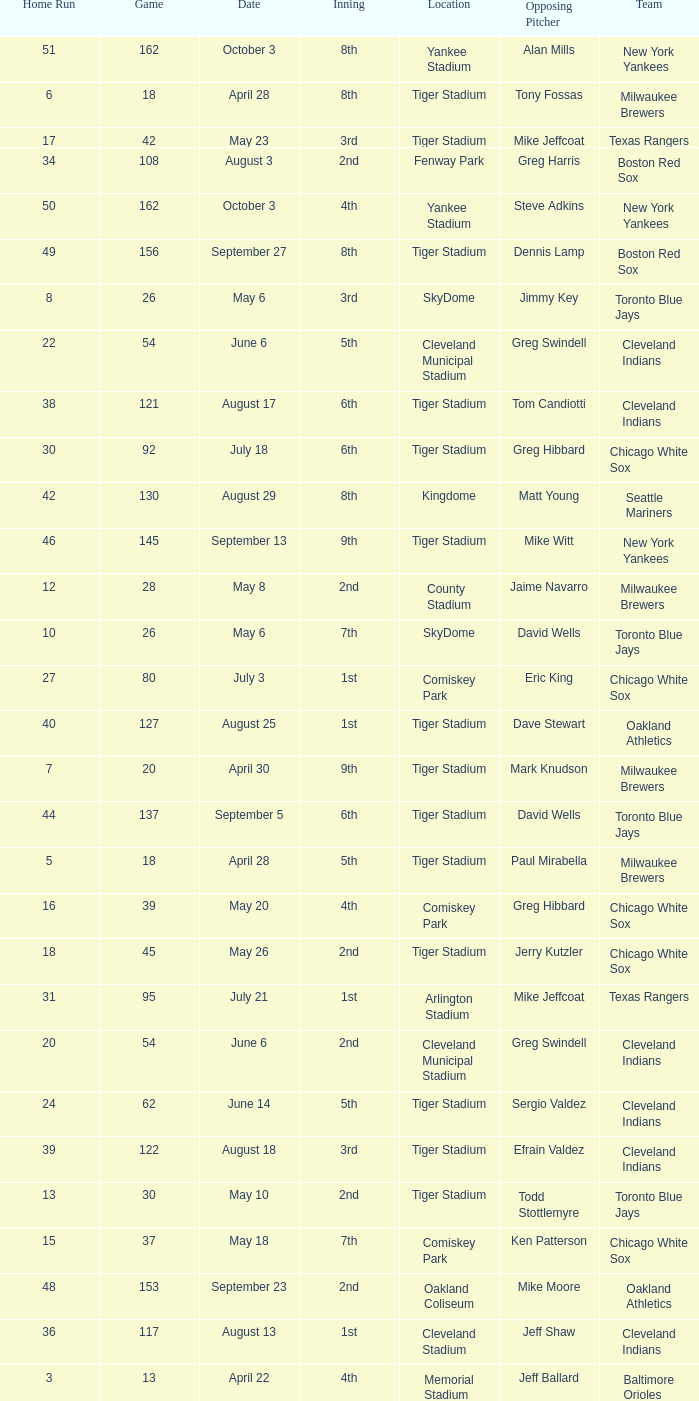During efrain valdez's pitching, what was the maximum home run? 39.0. Help me parse the entirety of this table. {'header': ['Home Run', 'Game', 'Date', 'Inning', 'Location', 'Opposing Pitcher', 'Team'], 'rows': [['51', '162', 'October 3', '8th', 'Yankee Stadium', 'Alan Mills', 'New York Yankees'], ['6', '18', 'April 28', '8th', 'Tiger Stadium', 'Tony Fossas', 'Milwaukee Brewers'], ['17', '42', 'May 23', '3rd', 'Tiger Stadium', 'Mike Jeffcoat', 'Texas Rangers'], ['34', '108', 'August 3', '2nd', 'Fenway Park', 'Greg Harris', 'Boston Red Sox'], ['50', '162', 'October 3', '4th', 'Yankee Stadium', 'Steve Adkins', 'New York Yankees'], ['49', '156', 'September 27', '8th', 'Tiger Stadium', 'Dennis Lamp', 'Boston Red Sox'], ['8', '26', 'May 6', '3rd', 'SkyDome', 'Jimmy Key', 'Toronto Blue Jays'], ['22', '54', 'June 6', '5th', 'Cleveland Municipal Stadium', 'Greg Swindell', 'Cleveland Indians'], ['38', '121', 'August 17', '6th', 'Tiger Stadium', 'Tom Candiotti', 'Cleveland Indians'], ['30', '92', 'July 18', '6th', 'Tiger Stadium', 'Greg Hibbard', 'Chicago White Sox'], ['42', '130', 'August 29', '8th', 'Kingdome', 'Matt Young', 'Seattle Mariners'], ['46', '145', 'September 13', '9th', 'Tiger Stadium', 'Mike Witt', 'New York Yankees'], ['12', '28', 'May 8', '2nd', 'County Stadium', 'Jaime Navarro', 'Milwaukee Brewers'], ['10', '26', 'May 6', '7th', 'SkyDome', 'David Wells', 'Toronto Blue Jays'], ['27', '80', 'July 3', '1st', 'Comiskey Park', 'Eric King', 'Chicago White Sox'], ['40', '127', 'August 25', '1st', 'Tiger Stadium', 'Dave Stewart', 'Oakland Athletics'], ['7', '20', 'April 30', '9th', 'Tiger Stadium', 'Mark Knudson', 'Milwaukee Brewers'], ['44', '137', 'September 5', '6th', 'Tiger Stadium', 'David Wells', 'Toronto Blue Jays'], ['5', '18', 'April 28', '5th', 'Tiger Stadium', 'Paul Mirabella', 'Milwaukee Brewers'], ['16', '39', 'May 20', '4th', 'Comiskey Park', 'Greg Hibbard', 'Chicago White Sox'], ['18', '45', 'May 26', '2nd', 'Tiger Stadium', 'Jerry Kutzler', 'Chicago White Sox'], ['31', '95', 'July 21', '1st', 'Arlington Stadium', 'Mike Jeffcoat', 'Texas Rangers'], ['20', '54', 'June 6', '2nd', 'Cleveland Municipal Stadium', 'Greg Swindell', 'Cleveland Indians'], ['24', '62', 'June 14', '5th', 'Tiger Stadium', 'Sergio Valdez', 'Cleveland Indians'], ['39', '122', 'August 18', '3rd', 'Tiger Stadium', 'Efrain Valdez', 'Cleveland Indians'], ['13', '30', 'May 10', '2nd', 'Tiger Stadium', 'Todd Stottlemyre', 'Toronto Blue Jays'], ['15', '37', 'May 18', '7th', 'Comiskey Park', 'Ken Patterson', 'Chicago White Sox'], ['48', '153', 'September 23', '2nd', 'Oakland Coliseum', 'Mike Moore', 'Oakland Athletics'], ['36', '117', 'August 13', '1st', 'Cleveland Stadium', 'Jeff Shaw', 'Cleveland Indians'], ['3', '13', 'April 22', '4th', 'Memorial Stadium', 'Jeff Ballard', 'Baltimore Orioles'], ['32', '98', 'July 24', '3rd', 'Tiger Stadium', 'John Mitchell', 'Baltimore Orioles'], ['25', '65', 'June 17', '7th', 'Tiger Stadium', 'Chuck Finley', 'California Angels'], ['37', '120', 'August 16', '3rd', 'Tiger Stadium', 'Ron Robinson', 'Milwaukee Brewers'], ['21', '54', 'June 6', '4th', 'Cleveland Municipal Stadium', 'Greg Swindell', 'Cleveland Indians'], ['28', '83', 'July 6', '4th', 'Tiger Stadium', 'Tom Gordon', 'Kansas City Royals'], ['2', '9', 'April 18', '5th', 'Tiger Stadium', 'Clay Parker', 'New York Yankees'], ['4', '15', 'April 24', '9th', 'Metrodome', 'John Candelaria', 'Minnesota Twins'], ['23', '61', 'June 13', '2nd', 'Tiger Stadium', 'John Farrell', 'Cleveland Indians'], ['47', '148', 'September 16', '5th', 'Tiger Stadium', 'Mark Leiter', 'New York Yankees'], ['33', '104', 'July 30', '4th', 'Yankee Stadium', 'Dave LaPoint', 'New York Yankees'], ['43', '135', 'September 3', '6th', 'Tiger Stadium', 'Jimmy Key', 'Toronto Blue Jays'], ['19', '50', 'June 1', '2nd', 'Kingdome', 'Matt Young', 'Seattle Mariners'], ['45', '139', 'September 7', '6th', 'County Stadium', 'Ted Higuera', 'Milwaukee Brewers'], ['41', '127', 'August 25', '4th', 'Tiger Stadium', 'Dave Stewart', 'Oakland Athletics'], ['1', '6', 'April 14', '6th', 'Tiger Stadium', 'Dave Johnson', 'Baltimore Orioles'], ['26', '77', 'June 30', '5th', 'Royals Stadium', 'Storm Davis', 'Kansas City Royals'], ['9', '26', 'May 6', '5th', 'SkyDome', 'Jimmy Key', 'Toronto Blue Jays'], ['11', '27', 'May 7', '4th', 'County Stadium', 'Mark Knudson', 'Milwaukee Brewers'], ['29', '87', 'July 13', '6th', 'Tiger Stadium', 'Bobby Witt', 'Texas Rangers'], ['14', '34', 'May 15', '7th', 'Arlington Stadium', 'Kevin Brown', 'Texas Rangers'], ['35', '111', 'August 7', '9th', 'Skydome', 'Jimmy Key', 'Toronto Blue Jays']]} 